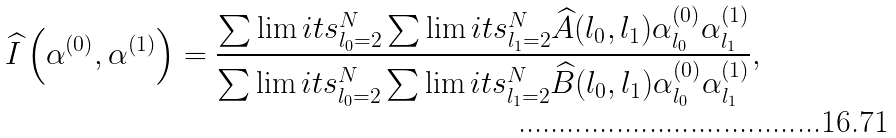<formula> <loc_0><loc_0><loc_500><loc_500>\widehat { I } \left ( \alpha ^ { ( 0 ) } , \alpha ^ { ( 1 ) } \right ) = \frac { \sum \lim i t s _ { l _ { 0 } = 2 } ^ { N } \sum \lim i t s _ { l _ { 1 } = 2 } ^ { N } \widehat { A } ( l _ { 0 } , l _ { 1 } ) \alpha _ { l _ { 0 } } ^ { ( 0 ) } \alpha _ { l _ { 1 } } ^ { ( 1 ) } } { \sum \lim i t s _ { l _ { 0 } = 2 } ^ { N } \sum \lim i t s _ { l _ { 1 } = 2 } ^ { N } \widehat { B } ( l _ { 0 } , l _ { 1 } ) \alpha _ { l _ { 0 } } ^ { ( 0 ) } \alpha _ { l _ { 1 } } ^ { ( 1 ) } } ,</formula> 